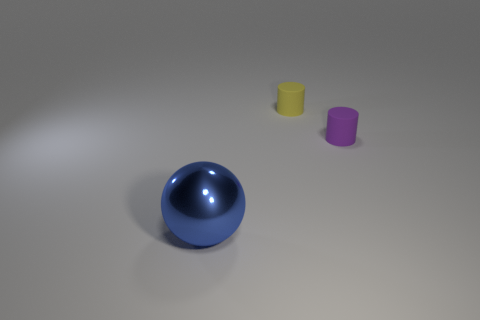Add 3 small yellow cylinders. How many objects exist? 6 Subtract all spheres. How many objects are left? 2 Subtract all tiny rubber things. Subtract all yellow metal spheres. How many objects are left? 1 Add 1 small yellow matte cylinders. How many small yellow matte cylinders are left? 2 Add 2 blue metal balls. How many blue metal balls exist? 3 Subtract 0 red cylinders. How many objects are left? 3 